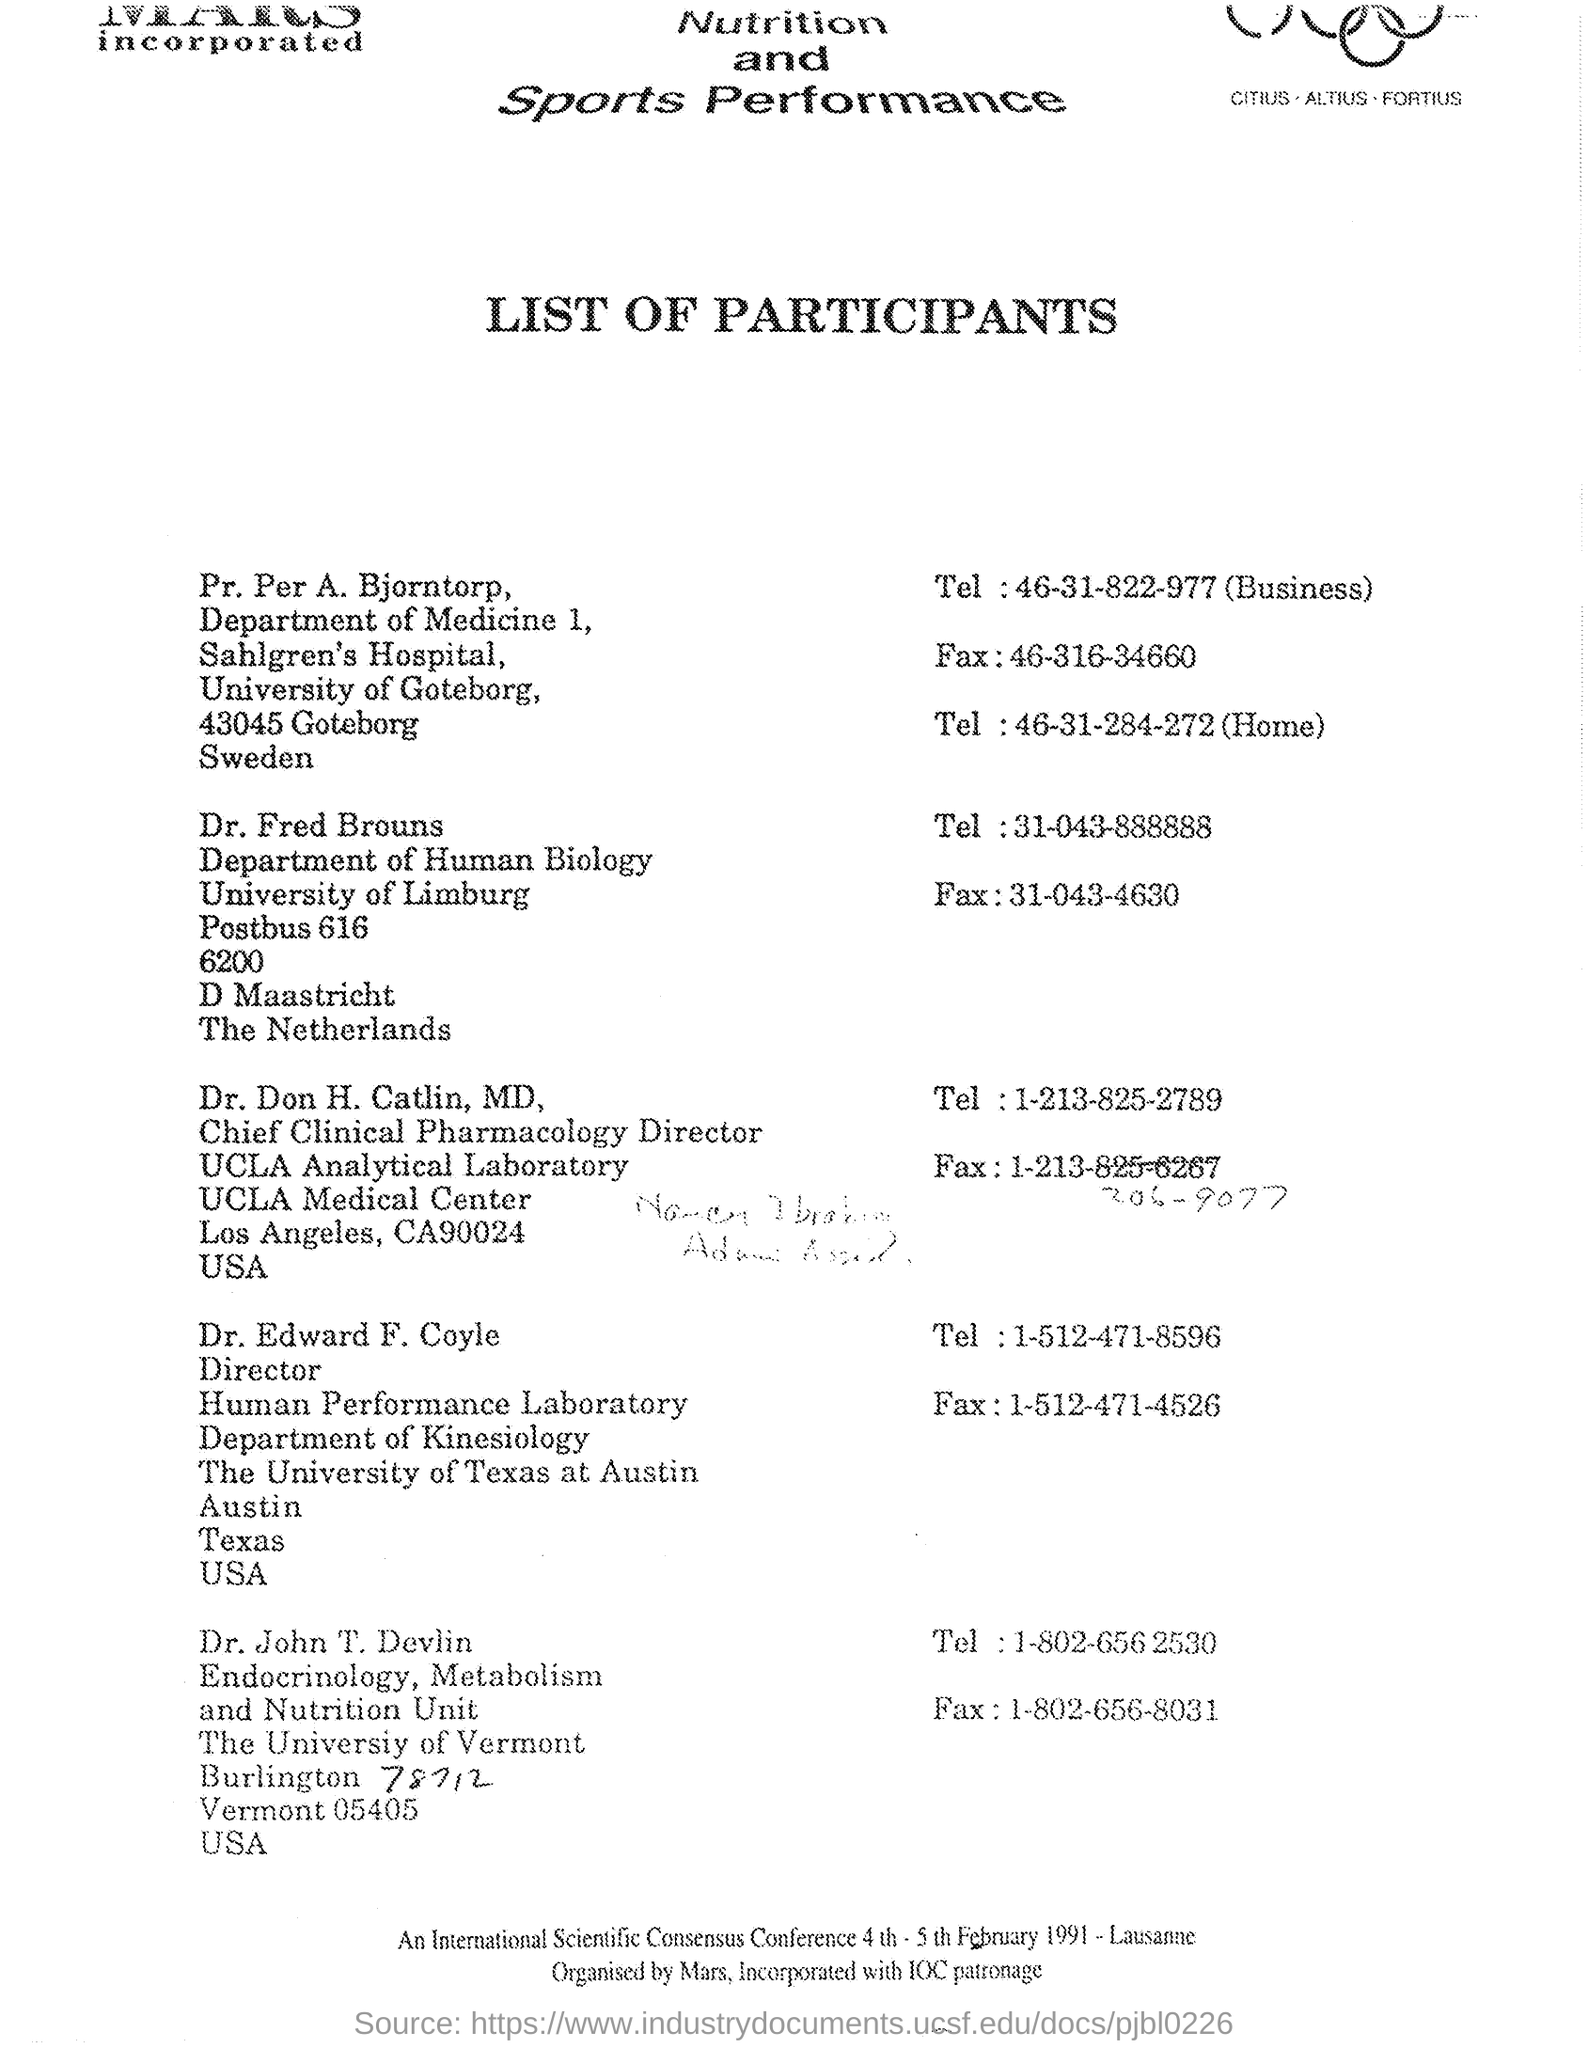Highlight a few significant elements in this photo. Dr. Edward F. Coyle is designated as the director. Dr. John T. Devlin is affiliated with the University of Vermont. Dr. Edward F. Coyle belongs to the Department of Kinesiology. The name of the university of Dr. Fred Brouns is the University of Limburg. Professor Per A. Bjorntorp is affiliated with the University of Gothenburg. 